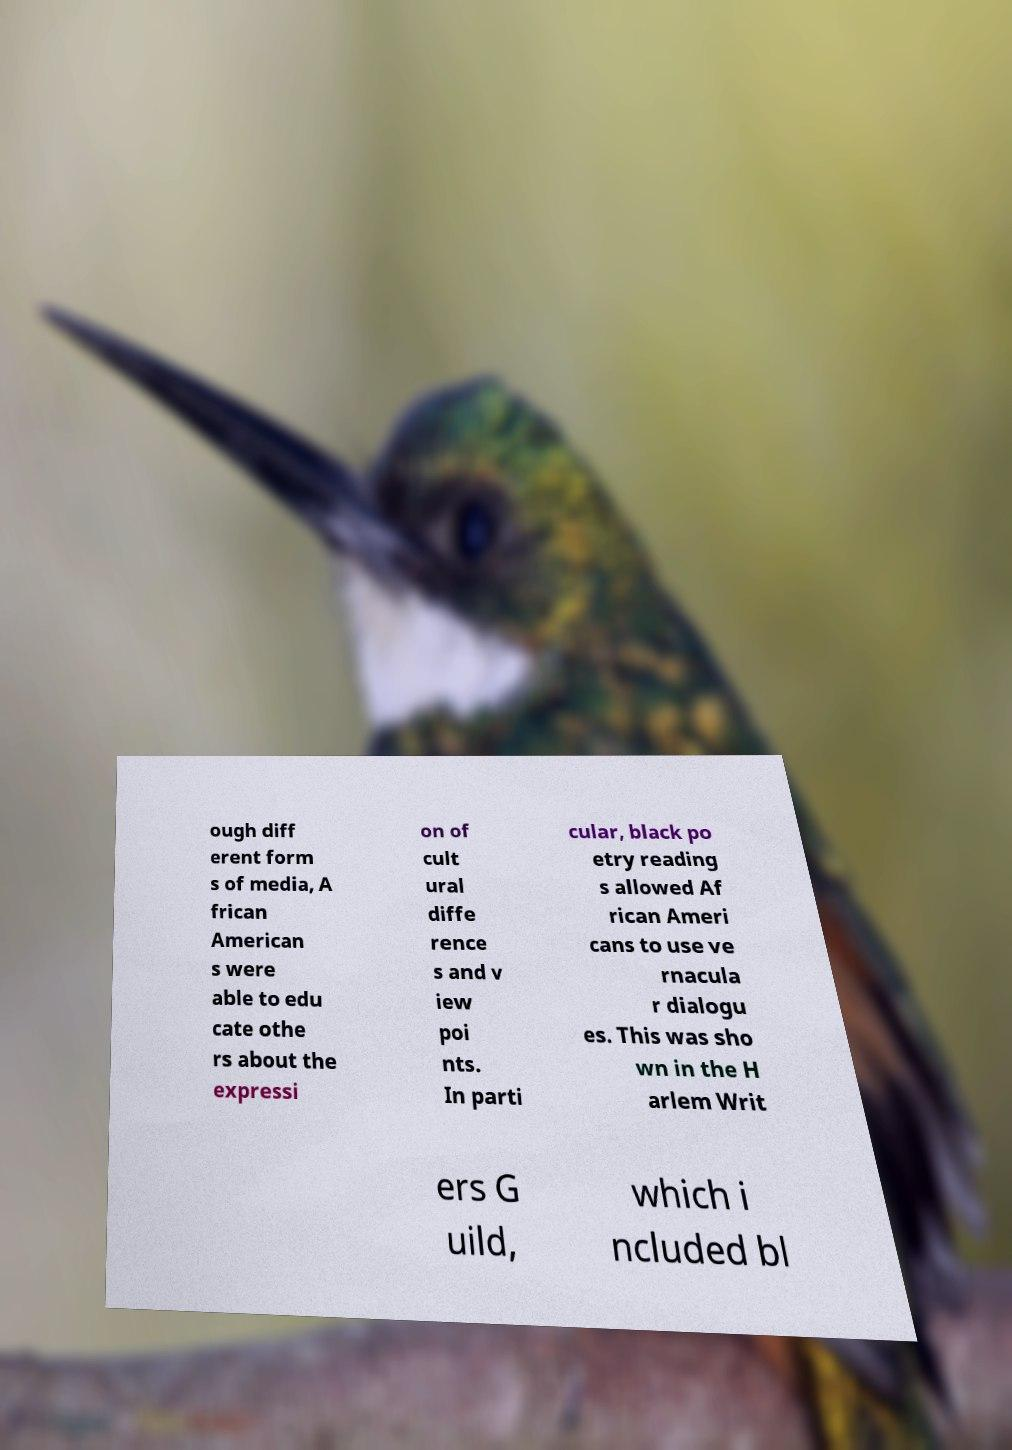Please read and relay the text visible in this image. What does it say? ough diff erent form s of media, A frican American s were able to edu cate othe rs about the expressi on of cult ural diffe rence s and v iew poi nts. In parti cular, black po etry reading s allowed Af rican Ameri cans to use ve rnacula r dialogu es. This was sho wn in the H arlem Writ ers G uild, which i ncluded bl 